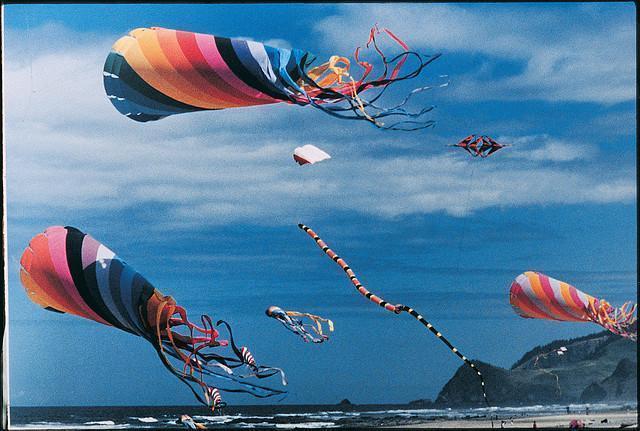What do the kites resemble?
Select the accurate answer and provide explanation: 'Answer: answer
Rationale: rationale.'
Options: Squid, tiger, dog, monkey. Answer: squid.
Rationale: The kites have large bulbous sections with tentacle like ribbons and streamers. 